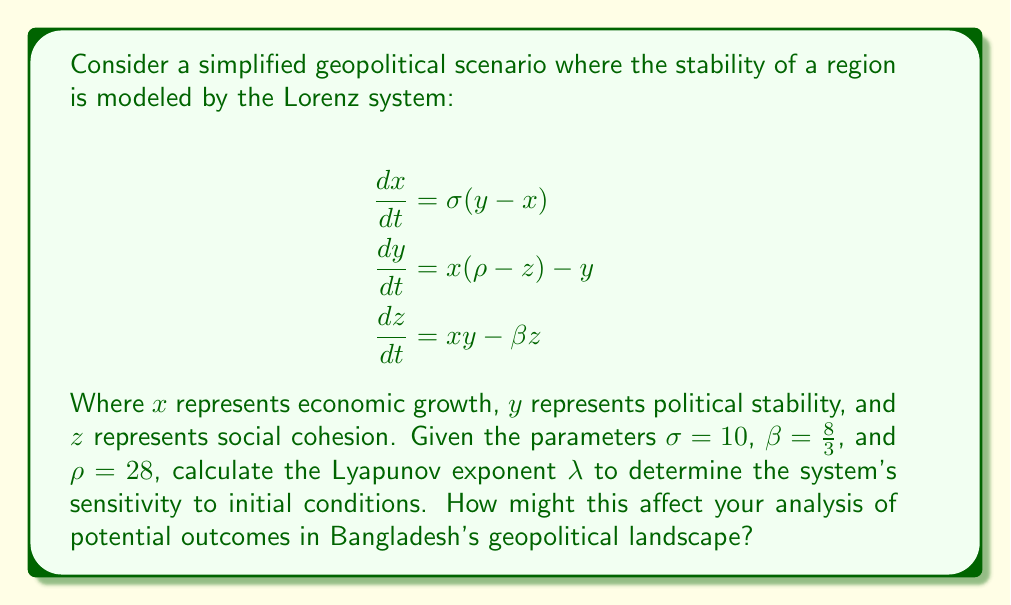Could you help me with this problem? To solve this problem, we need to follow these steps:

1) The Lyapunov exponent $\lambda$ for the Lorenz system is given by:

   $$\lambda = \sigma + \rho + \beta - (\sigma + 1 + \frac{\sigma\rho}{\sigma + \beta + 1})$$

2) Substitute the given values:
   $\sigma = 10$, $\beta = \frac{8}{3}$, and $\rho = 28$

3) Calculate:
   $$\lambda = 10 + 28 + \frac{8}{3} - (10 + 1 + \frac{10 * 28}{10 + \frac{8}{3} + 1})$$

4) Simplify:
   $$\lambda = 40\frac{2}{3} - (11 + \frac{280}{13\frac{2}{3}})$$
   $$\lambda = 40.67 - (11 + 20.73)$$
   $$\lambda = 40.67 - 31.73$$
   $$\lambda = 8.94$$

5) Interpret the result:
   A positive Lyapunov exponent ($\lambda > 0$) indicates that the system is chaotic and highly sensitive to initial conditions.

6) Apply to geopolitical analysis:
   This high sensitivity suggests that small changes in economic, political, or social factors could lead to significantly different outcomes in Bangladesh's geopolitical landscape. As an OSINT analyst, you should be aware that:
   
   a) Minor economic fluctuations could have far-reaching consequences on political stability and social cohesion.
   b) Small political decisions or events might drastically alter the economic trajectory and social dynamics.
   c) Subtle changes in social factors could impact both economic growth and political stability in unpredictable ways.

   Therefore, your analysis should consider multiple scenarios and be frequently updated as new information becomes available, acknowledging the inherent unpredictability in the system.
Answer: $\lambda = 8.94$; highly sensitive to initial conditions 